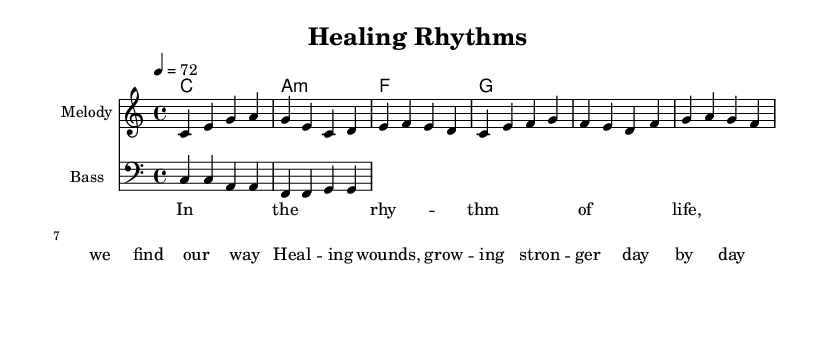What is the key signature of this music? The key signature is C major, which is indicated by the absence of sharps or flats. A glance at the key signature at the beginning confirms it aligns with the C major scale.
Answer: C major What is the time signature of this music? The time signature is 4/4, which is notated at the beginning of the sheet music. This indicates there are four beats per measure and a quarter note receives one beat.
Answer: 4/4 What is the tempo marking in beats per minute? The tempo marking is set at 72 BPM, indicated at the beginning of the score. This means the piece is intended to be played at 72 beats per minute.
Answer: 72 How many measures are there in the melody? The melody consists of four measures, as each set of horizontal lines and notes indicates a measure, and there are four grouped sections.
Answer: 4 What is the instrument specified for the melody? The instrument specified for the melody is labeled as "Melody" at the beginning of the corresponding staff. This indicates that the melody part is to be played on an instrument like a flute or guitar.
Answer: Melody What type of chords are predominantly used in this piece, and what is the first chord? The piece predominantly uses major and minor chords; the first chord shown is C major, indicated in the chord names section at the beginning, which corresponds with the main key of the piece.
Answer: C major What lyrical theme is expressed in the song? The lyrical theme expressed revolves around healing and personal growth, reflecting a sense of overcoming challenges as illustrated by the words used in the lyrics.
Answer: Healing and growth 